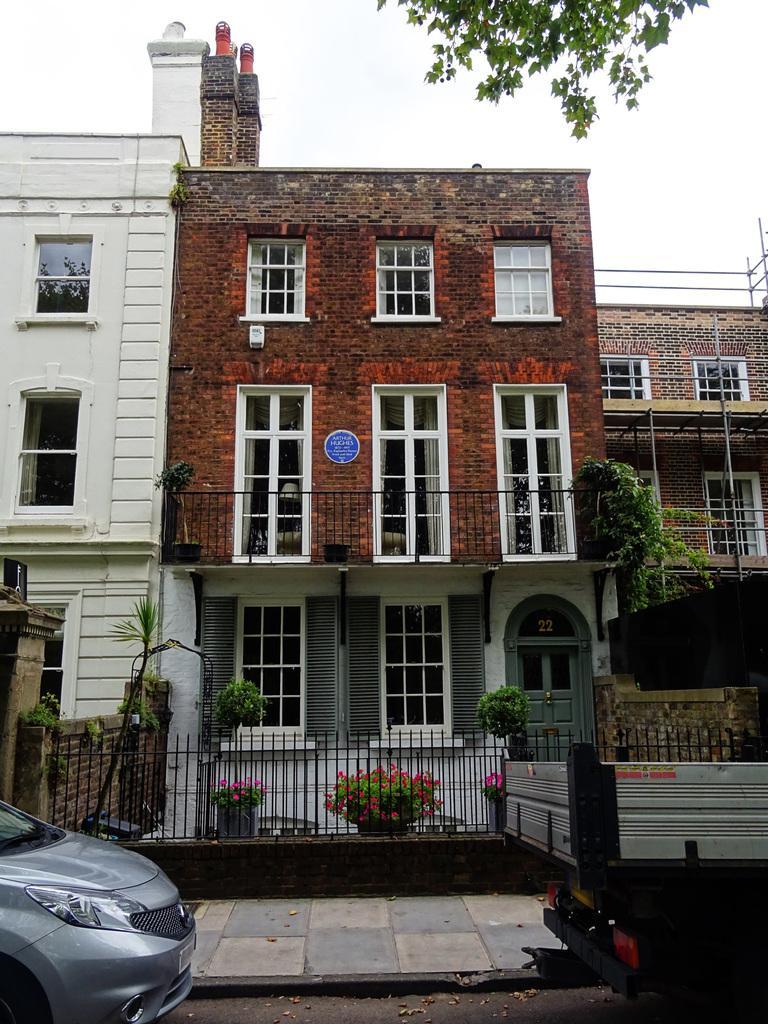Can you describe this image briefly? In this image there is the sky truncated towards the top of the image, there is a tree truncated towards the top of the image, there are buildings, there is a building truncated towards the left of the image, there is a building truncated towards the right of the image, there are windows, there is door, there is the wall, there are plants, there are flower pots, there is fencing, there is road truncated towards the bottom of the image, there is a vehicle truncated right of the image, there is a vehicle truncated towards the left of the image. 